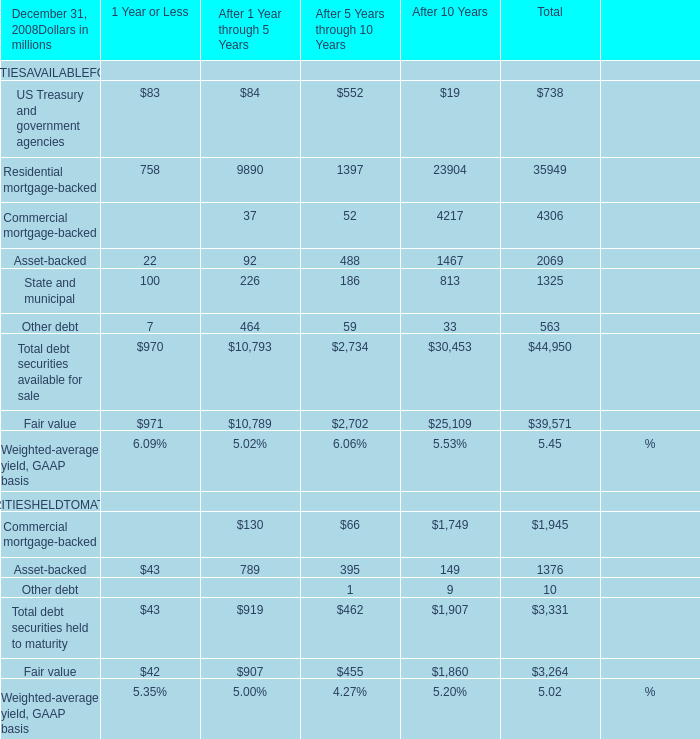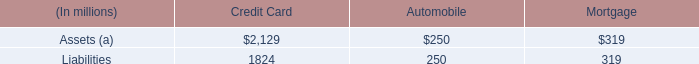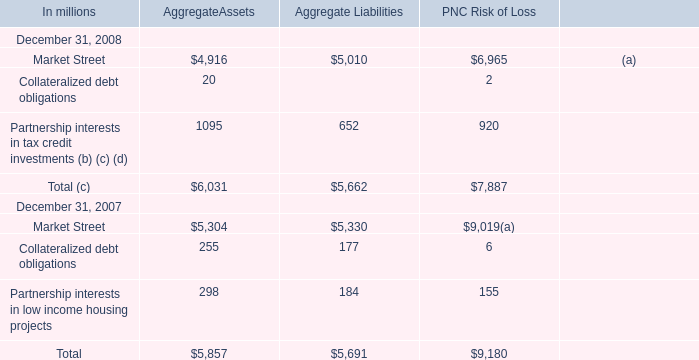In which section is US Treasury and government agencies smaller than Residential mortgage-backed in 2008? 
Answer: 1 Year or Less After 1 Year through 5 Years After 5 Years through 10 Years After 10 Years Total. 